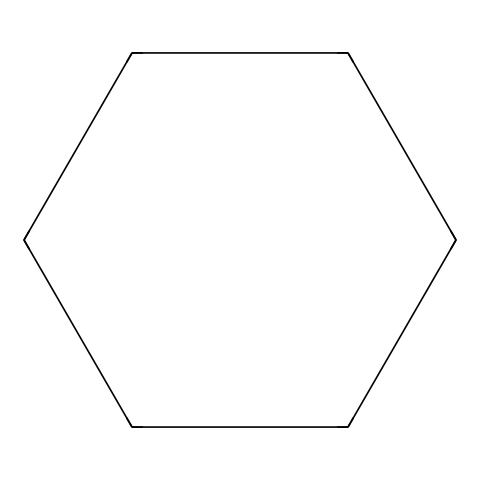What is the name of this chemical? This chemical is represented by the SMILES notation "C1CCCCC1", which corresponds to cyclohexane, a cycloalkane with six carbon atoms connected in a ring.
Answer: cyclohexane How many carbon atoms are in this structure? The SMILES "C1CCCCC1" indicates that there are six carbon atoms in the cyclohexane molecule, as the structure forms a closed ring with one carbon atom at each vertex.
Answer: six What type of compound is cyclohexane? Cyclohexane is a saturated hydrocarbon, belonging to the category of cycloalkanes due to its cyclic structure and single bonds between carbon atoms.
Answer: cycloalkane How many hydrogen atoms does cyclohexane have? Cyclohexane follows the formula CnH2n, where n is the number of carbon atoms. For six carbon atoms, the hydrogen count is 2 times 6, yielding twelve hydrogen atoms.
Answer: twelve Does cyclohexane contain any double or triple bonds? In the structure of cyclohexane, there are only single bonds connecting the carbon atoms, indicating there are no double or triple bonds present in the molecule.
Answer: no What is the hybridization of the carbon atoms in cyclohexane? Each carbon atom in cyclohexane is bonded to two hydrogen atoms and two other carbons. This arrangement corresponds to sp3 hybridization, as each carbon forms four single bonds in a tetrahedral geometry.
Answer: sp3 Is cyclohexane polar or nonpolar? Cyclohexane has a symmetrical structure and doesn't have significant differences in electronegativity between its atoms. This results in a nonpolar molecule overall, as it does not have a dipole moment.
Answer: nonpolar 